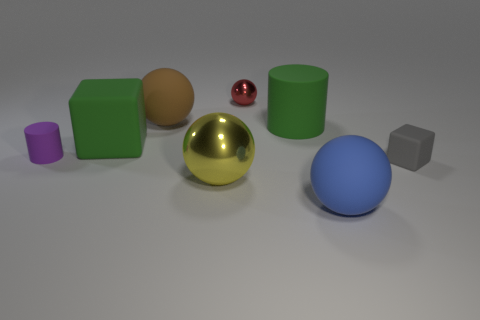Add 2 small rubber cylinders. How many objects exist? 10 Subtract all cylinders. How many objects are left? 6 Subtract all tiny purple matte objects. Subtract all brown rubber balls. How many objects are left? 6 Add 2 brown rubber things. How many brown rubber things are left? 3 Add 3 large balls. How many large balls exist? 6 Subtract 0 gray spheres. How many objects are left? 8 